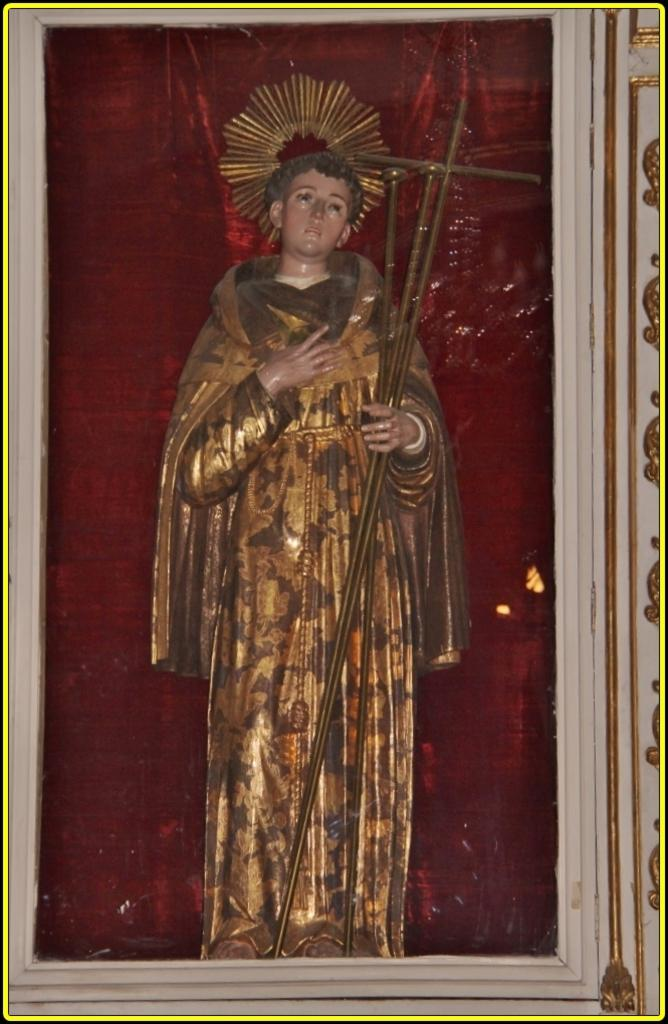What is the main subject of the image? The main subject of the image is a statue. How is the statue displayed in the image? The statue is inside a glass box. What color is the cloth visible in the image? The cloth visible in the image is red-colored. How many letters can be seen on the statue in the image? There are no letters visible on the statue in the image. What type of trains are passing by the statue in the image? There are no trains present in the image; it only features a statue inside a glass box and red-colored cloth. 